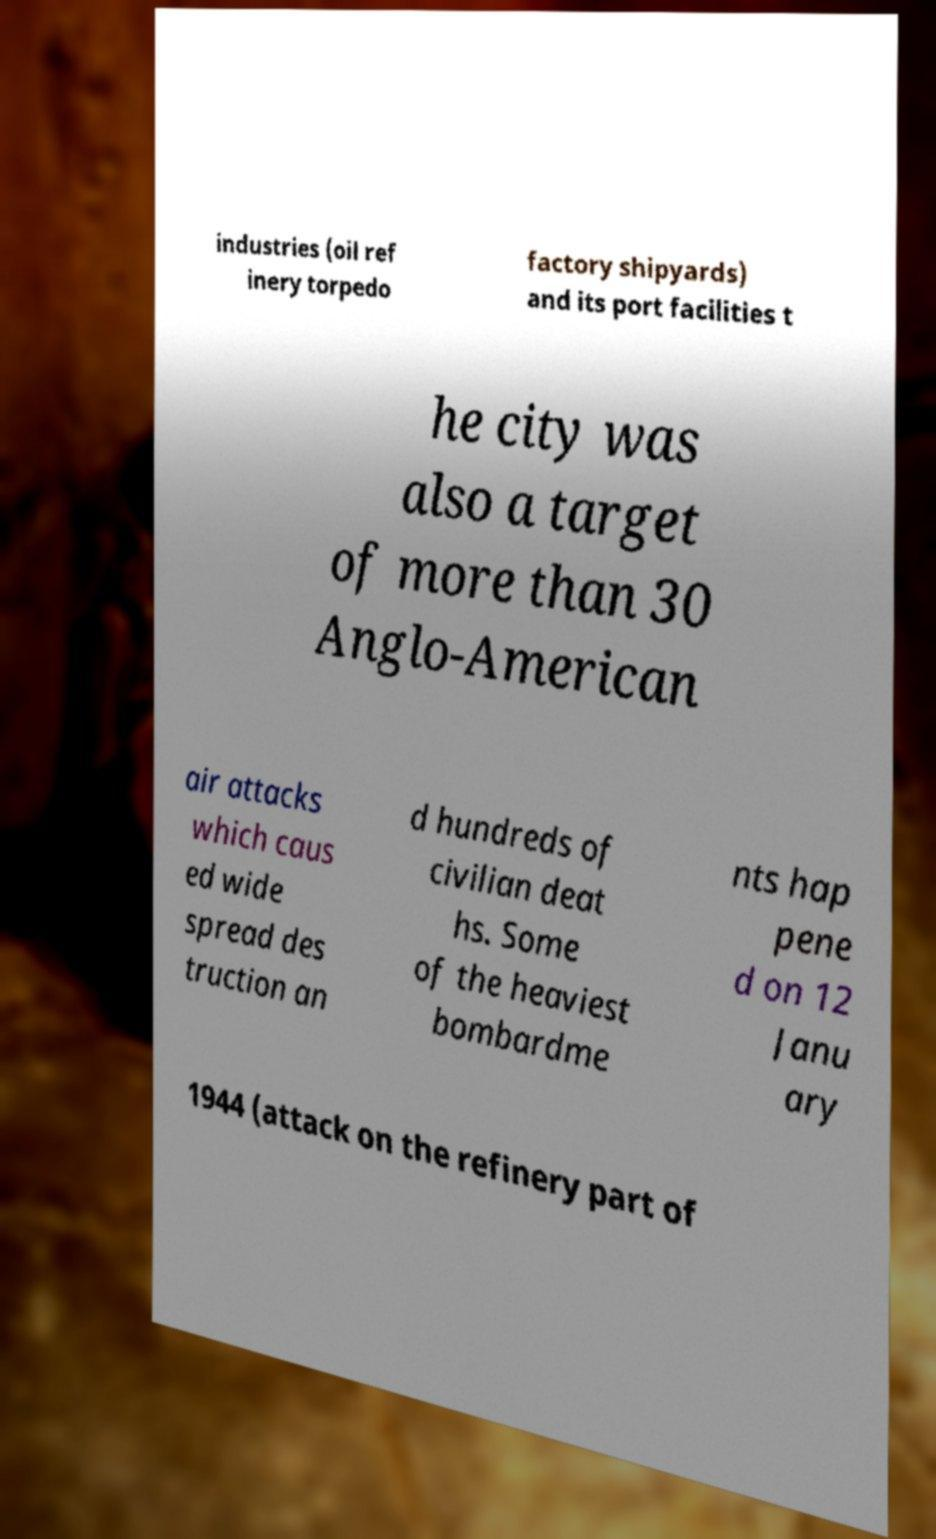Please read and relay the text visible in this image. What does it say? industries (oil ref inery torpedo factory shipyards) and its port facilities t he city was also a target of more than 30 Anglo-American air attacks which caus ed wide spread des truction an d hundreds of civilian deat hs. Some of the heaviest bombardme nts hap pene d on 12 Janu ary 1944 (attack on the refinery part of 